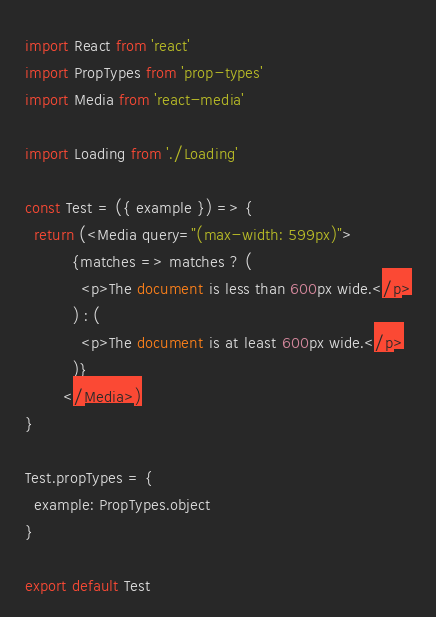Convert code to text. <code><loc_0><loc_0><loc_500><loc_500><_JavaScript_>import React from 'react'
import PropTypes from 'prop-types'
import Media from 'react-media'
 
import Loading from './Loading'

const Test = ({ example }) => {
  return (<Media query="(max-width: 599px)">
          {matches => matches ? (
            <p>The document is less than 600px wide.</p>
          ) : (
            <p>The document is at least 600px wide.</p>
          )}
        </Media>)
}

Test.propTypes = {
  example: PropTypes.object
}

export default Test
</code> 